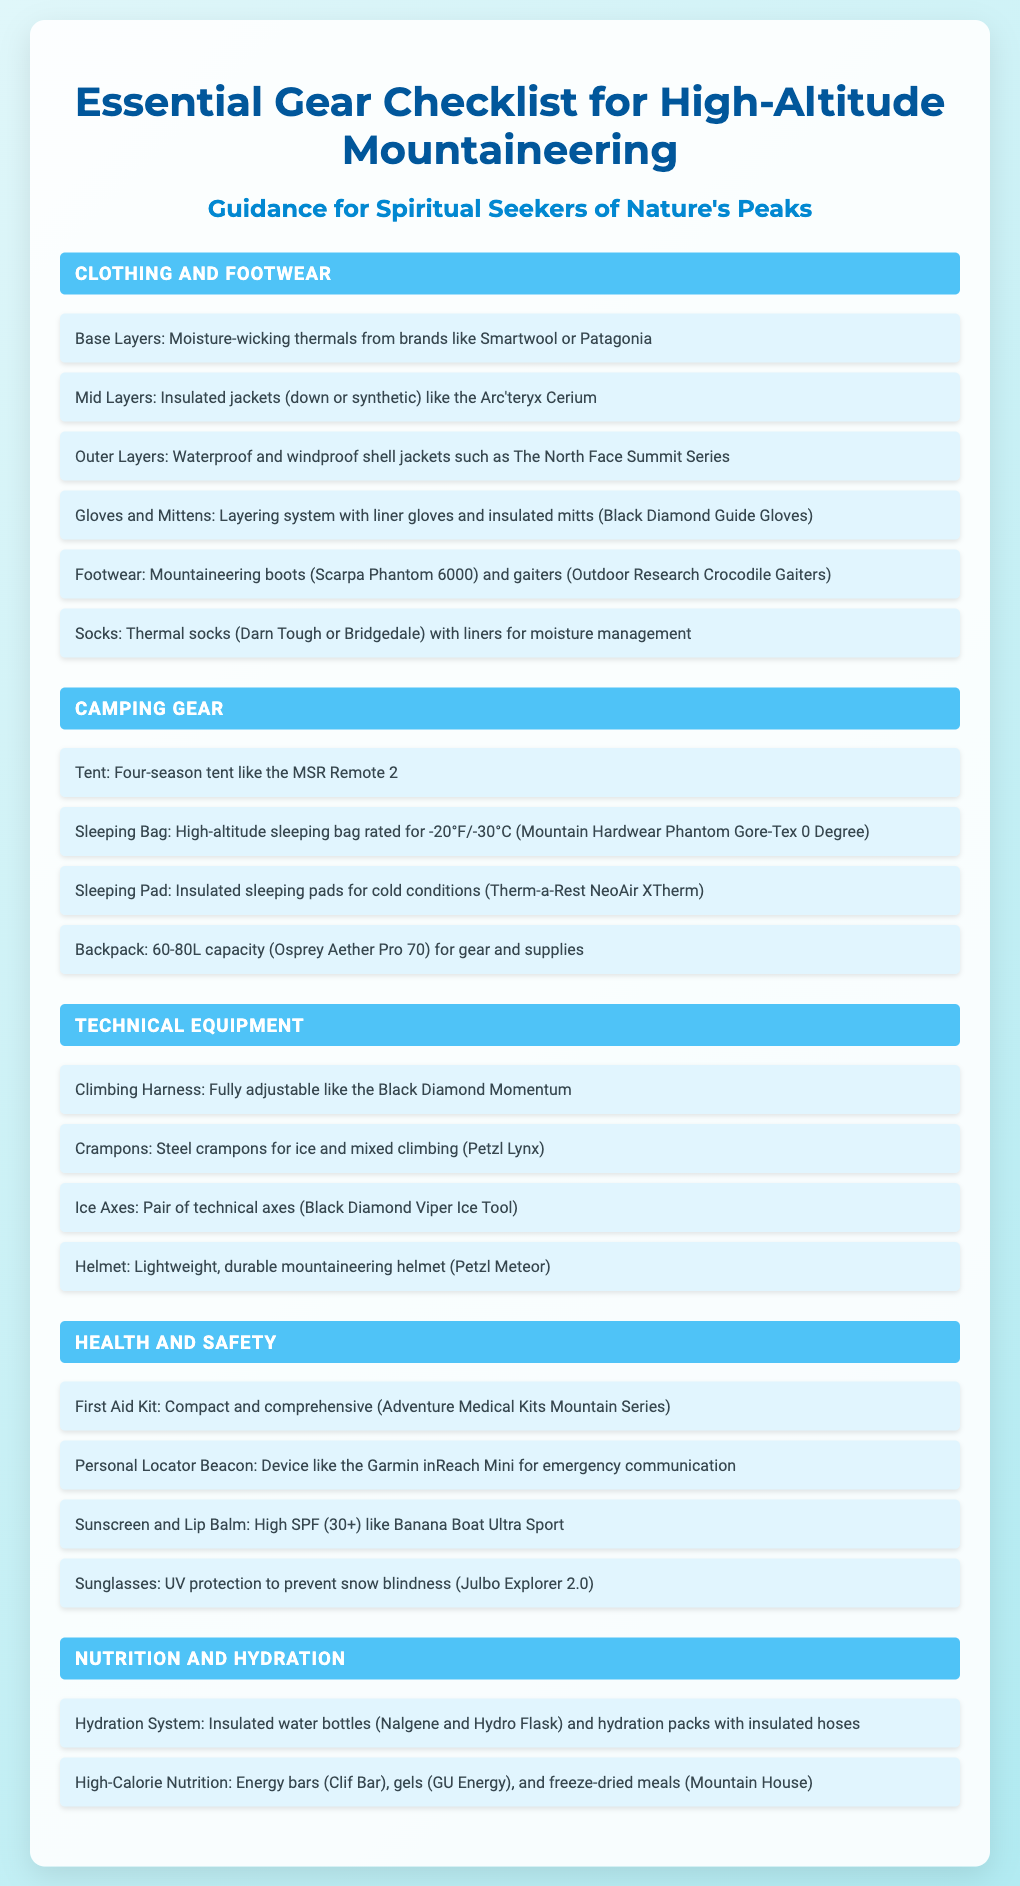What is the title of the document? The title of the document is prominently displayed at the top as "Essential Gear Checklist for High-Altitude Mountaineering."
Answer: Essential Gear Checklist for High-Altitude Mountaineering Which brand is mentioned for insulated jackets? The document lists Arc'teryx as a brand for insulated jackets in the clothing section.
Answer: Arc'teryx What is the recommended type of sleeping bag for high-altitude conditions? The checklist specifies a high-altitude sleeping bag rated for -20°F/-30°C.
Answer: -20°F/-30°C How many liters should a backpack have for gear and supplies? The backpack should have a capacity between 60 to 80 liters, as stated in the camping gear section.
Answer: 60-80L Which piece of equipment is used for ice and mixed climbing? The checklist indicates that steel crampons are used for ice and mixed climbing.
Answer: Steel crampons What are two examples of high-calorie nutrition listed in the document? The document mentions energy bars and freeze-dried meals as examples of high-calorie nutrition.
Answer: Energy bars, freeze-dried meals How many sections are there in the document? The document contains five distinct sections covering different aspects of high-altitude mountaineering gear.
Answer: Five What type of sunglasses does the document recommend? The document recommends sunglasses that provide UV protection to prevent snow blindness.
Answer: UV protection What is one item included in the health and safety section? The health and safety section includes a compact and comprehensive first aid kit.
Answer: First Aid Kit 